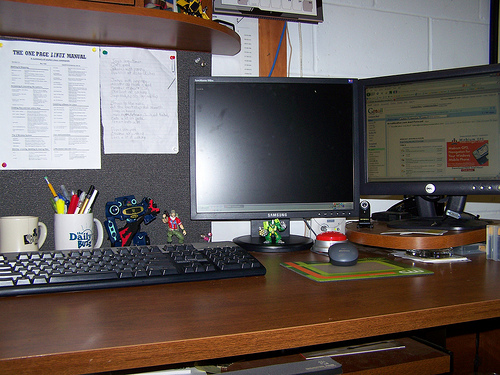<image>
Can you confirm if the keyboard is to the left of the monitor? Yes. From this viewpoint, the keyboard is positioned to the left side relative to the monitor. 